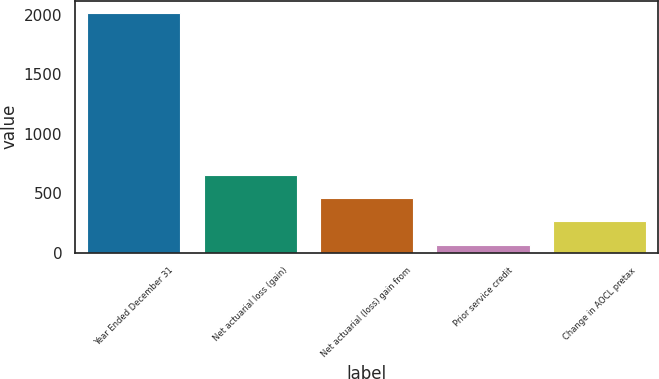<chart> <loc_0><loc_0><loc_500><loc_500><bar_chart><fcel>Year Ended December 31<fcel>Net actuarial loss (gain)<fcel>Net actuarial (loss) gain from<fcel>Prior service credit<fcel>Change in AOCL pretax<nl><fcel>2016<fcel>652.4<fcel>457.6<fcel>68<fcel>262.8<nl></chart> 